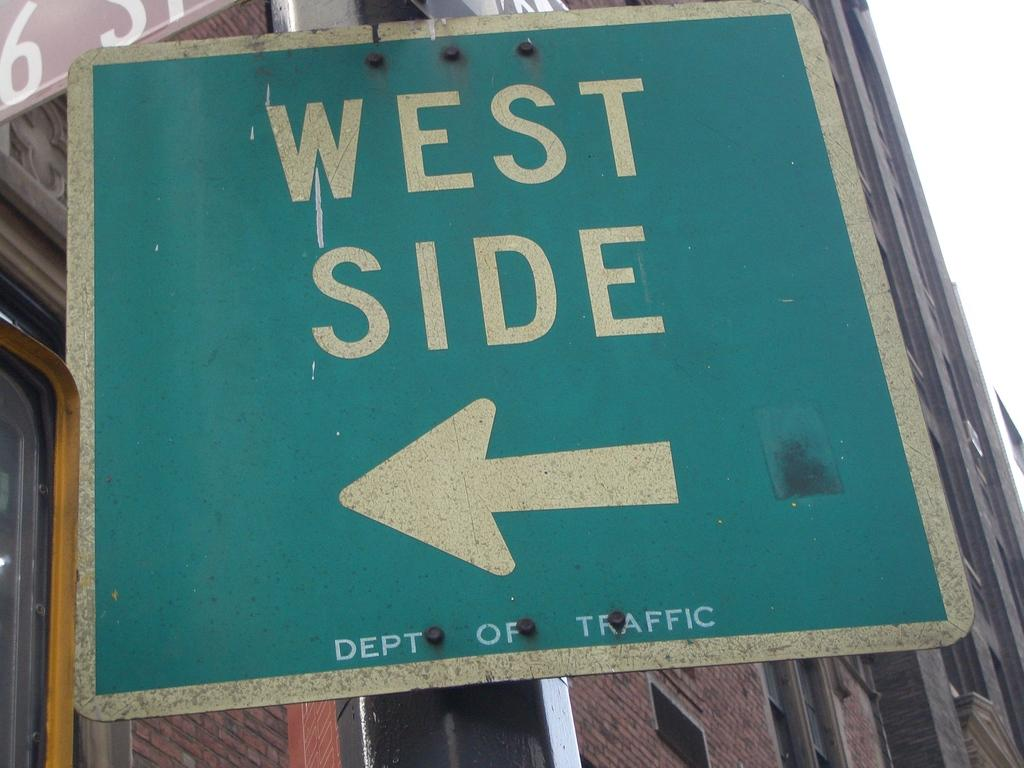What is the main object in the image? There is a direction board in the image. What can be seen on the left side of the direction board? There is a huge building on the left side of the direction board. What type of leather is used to cover the direction board in the image? There is no leather mentioned or visible in the image; the direction board is likely made of a different material. 